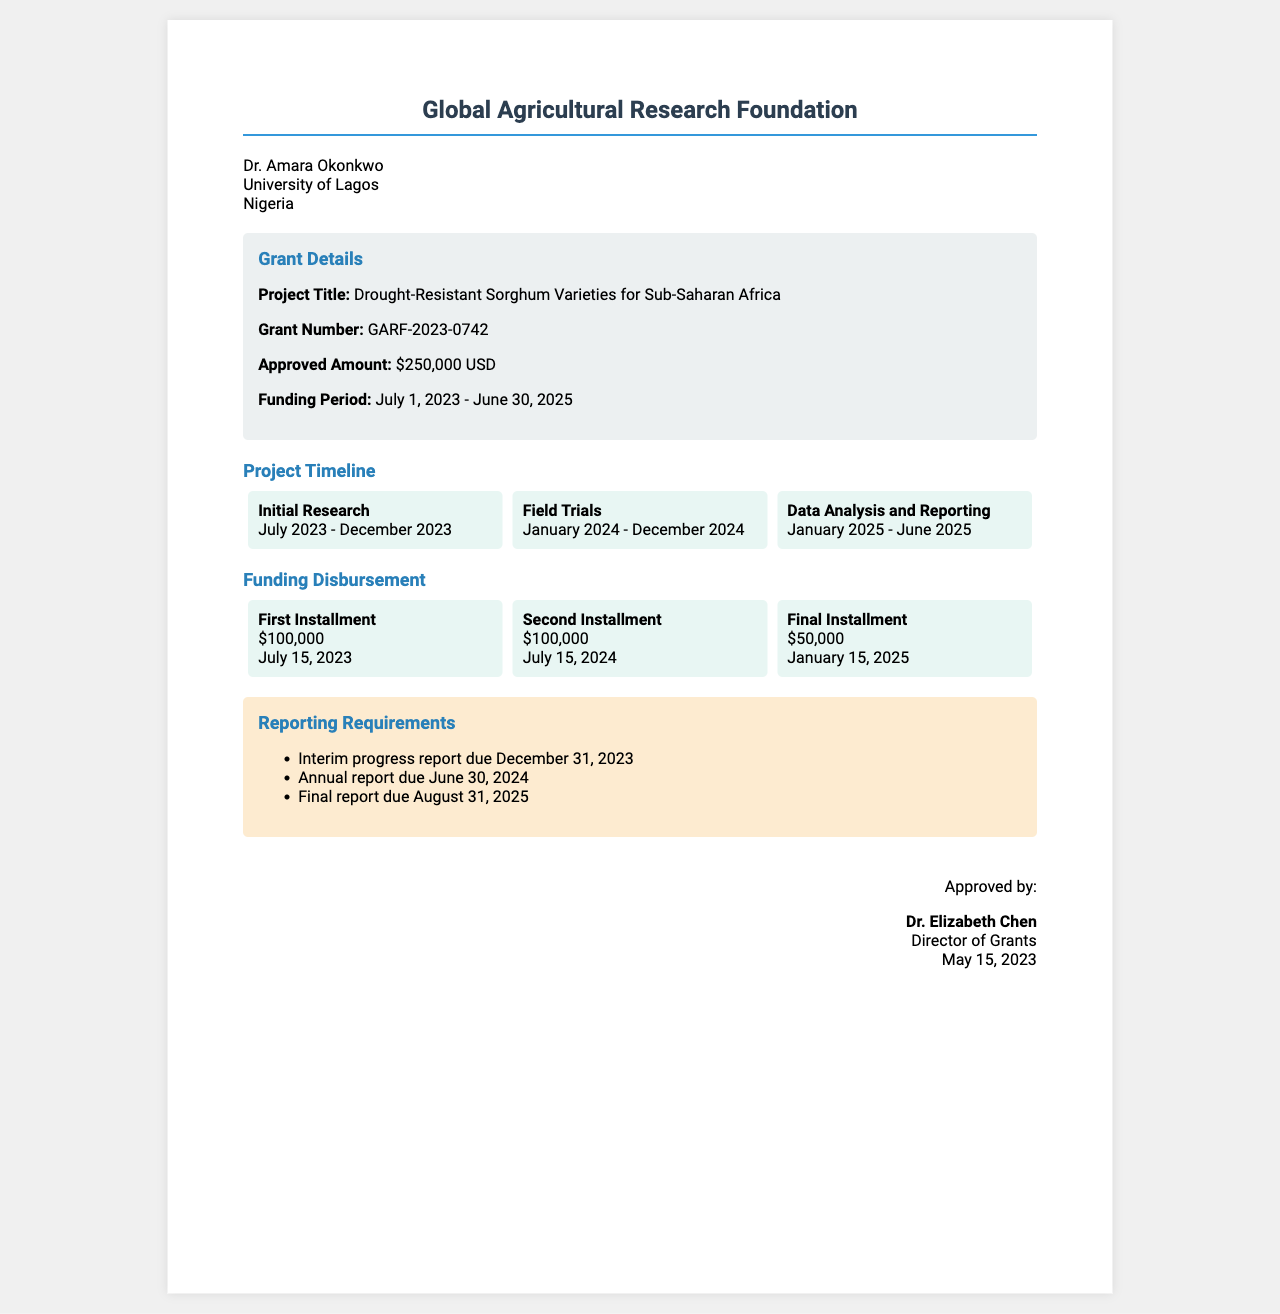What is the project title? The project title is explicitly mentioned in the grant details section of the document.
Answer: Drought-Resistant Sorghum Varieties for Sub-Saharan Africa What is the grant number? The grant number is provided in the grant details section of the document.
Answer: GARF-2023-0742 What is the approved amount for the grant? The approved amount is clearly stated in the grant details section of the document.
Answer: $250,000 USD What is the funding period? The funding period is specified in the grant details section, covering the start and end dates.
Answer: July 1, 2023 - June 30, 2025 When is the final installment scheduled for disbursement? The final installment date is provided in the funding disbursement section of the document.
Answer: January 15, 2025 How many installments will be disbursed? The number of installments is implied by the funding disbursement section showing three separate payments.
Answer: Three What is the due date for the interim progress report? The due date for the interim progress report is listed in the reporting requirements section of the document.
Answer: December 31, 2023 Who approved the grant? The person who approved the grant is mentioned at the end of the document under the signature section.
Answer: Dr. Elizabeth Chen What is the duration of the initial research phase? The duration of the initial research phase is noted in the project timeline section, specifying its start and end dates.
Answer: July 2023 - December 2023 What is the role of Dr. Elizabeth Chen? The document specifies Dr. Elizabeth Chen's role in the signature section at the bottom.
Answer: Director of Grants 